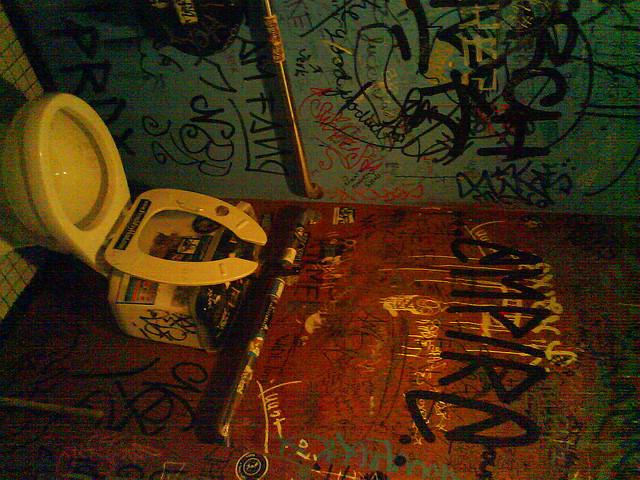What are the rails on the walls used for?
Write a very short answer. Support. Is this a men's or women's public restroom?
Answer briefly. Men's. Is this graffiti excessive?
Quick response, please. Yes. What is on graffiti?
Short answer required. Paint. 